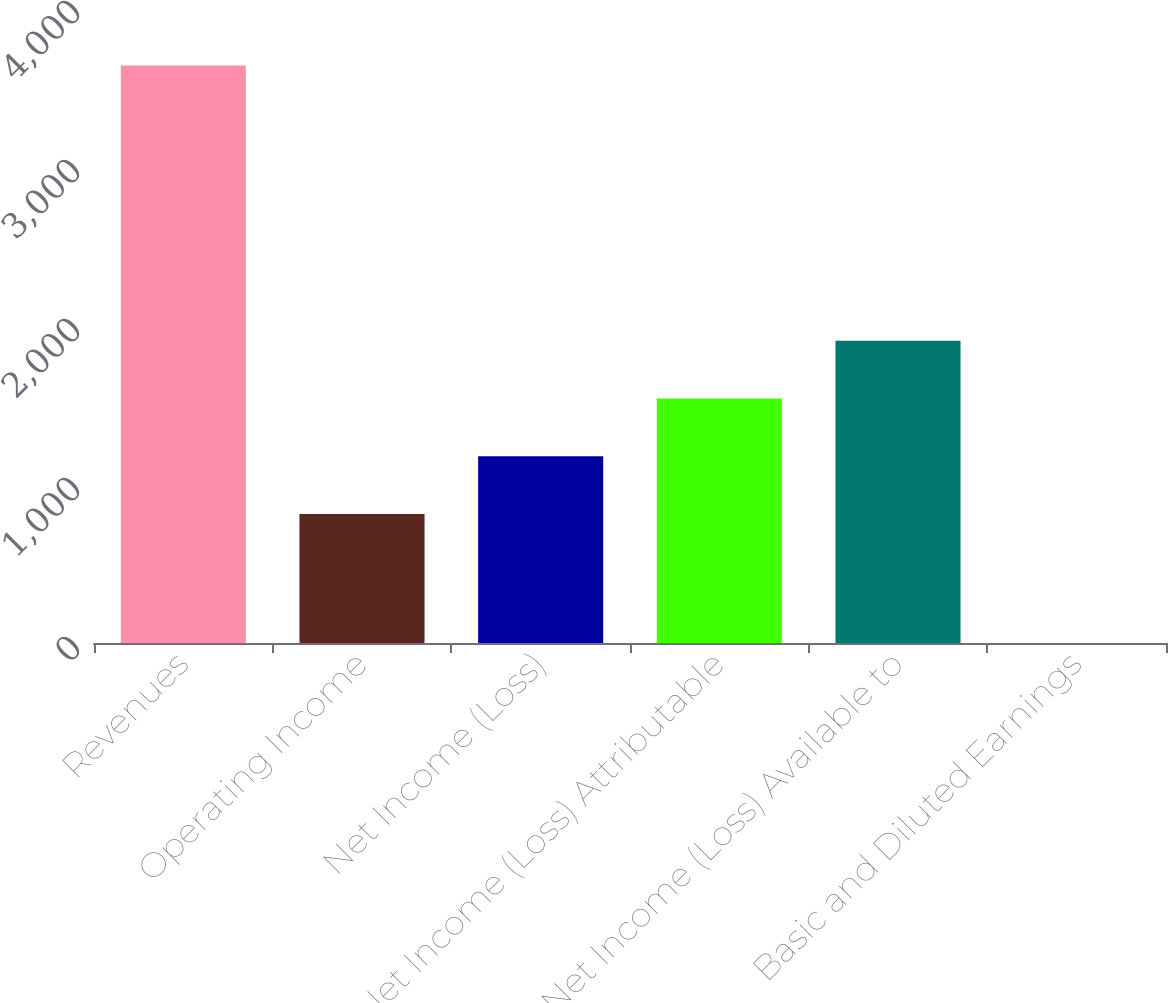<chart> <loc_0><loc_0><loc_500><loc_500><bar_chart><fcel>Revenues<fcel>Operating Income<fcel>Net Income (Loss)<fcel>Net Income (Loss) Attributable<fcel>Net Income (Loss) Available to<fcel>Basic and Diluted Earnings<nl><fcel>3632<fcel>812<fcel>1175.15<fcel>1538.3<fcel>1901.45<fcel>0.47<nl></chart> 